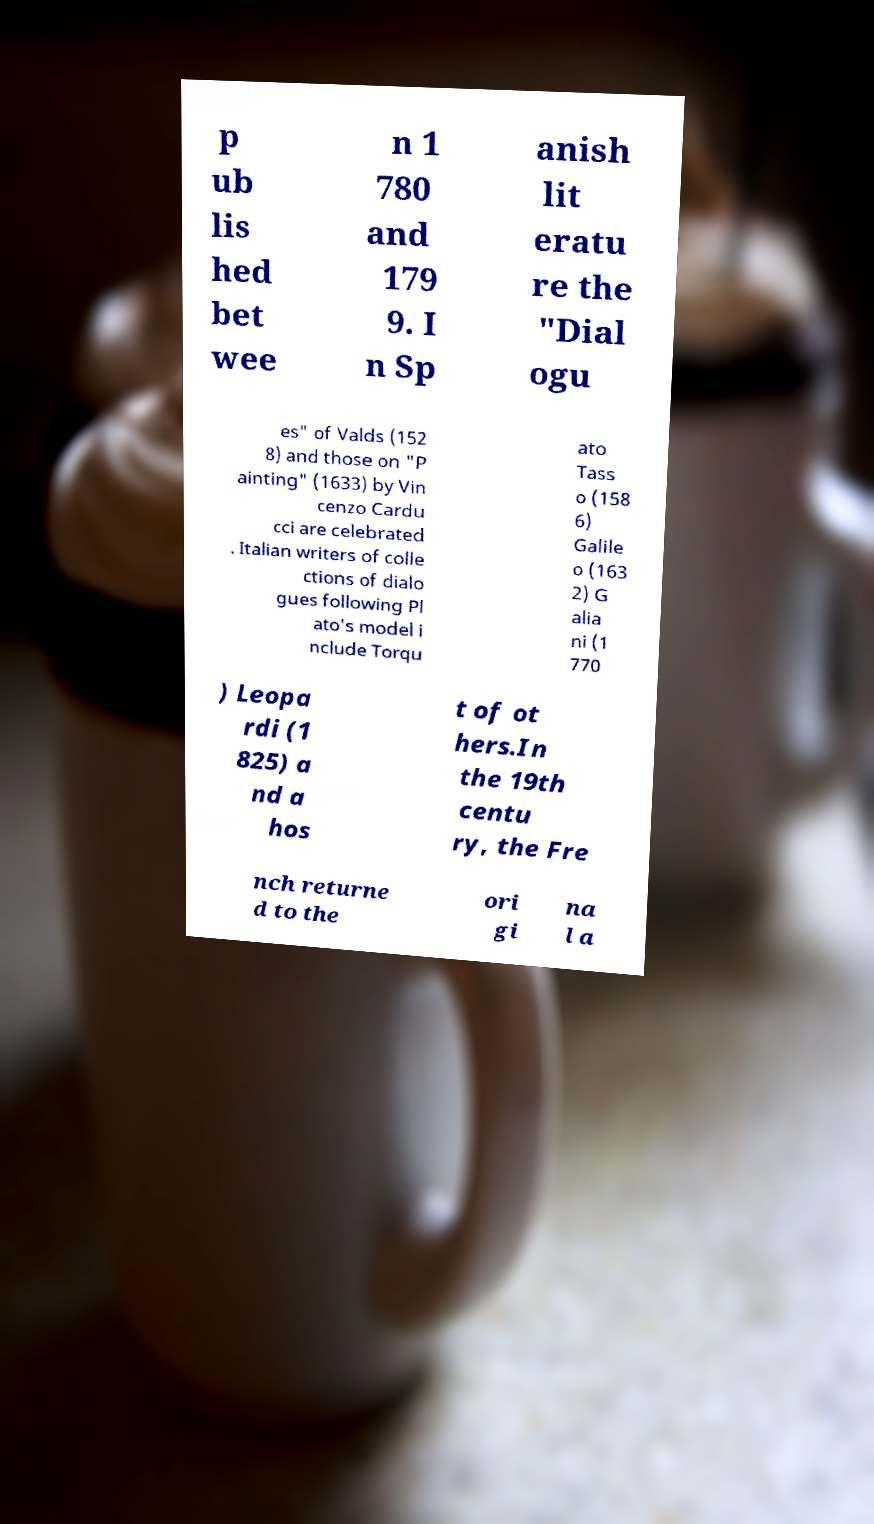What messages or text are displayed in this image? I need them in a readable, typed format. p ub lis hed bet wee n 1 780 and 179 9. I n Sp anish lit eratu re the "Dial ogu es" of Valds (152 8) and those on "P ainting" (1633) by Vin cenzo Cardu cci are celebrated . Italian writers of colle ctions of dialo gues following Pl ato's model i nclude Torqu ato Tass o (158 6) Galile o (163 2) G alia ni (1 770 ) Leopa rdi (1 825) a nd a hos t of ot hers.In the 19th centu ry, the Fre nch returne d to the ori gi na l a 